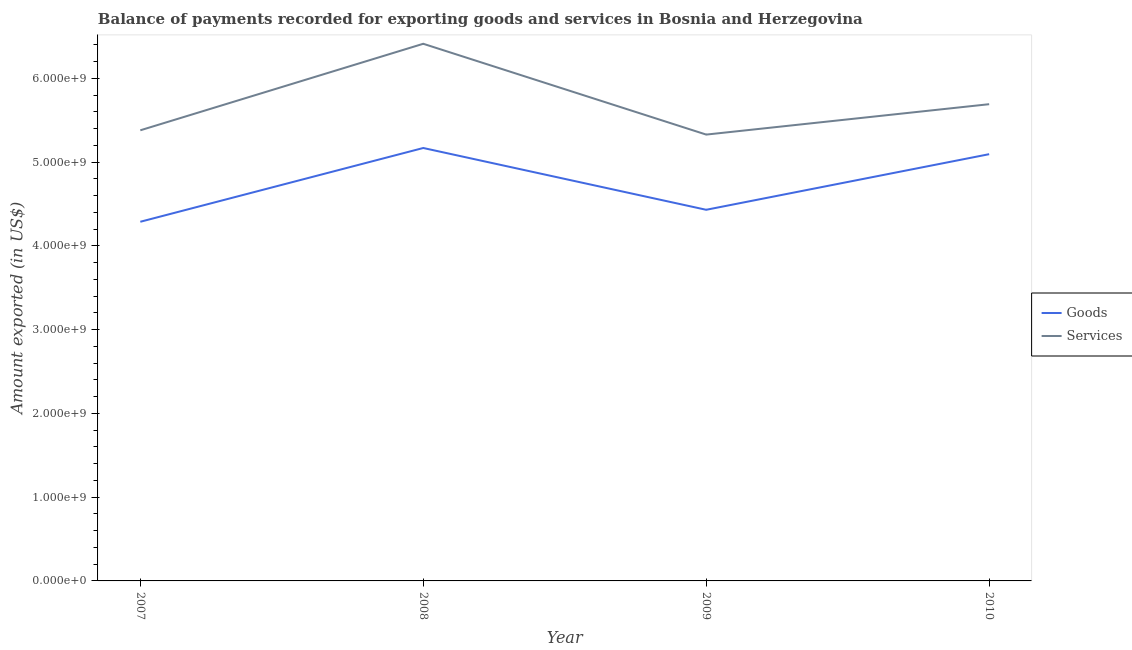Is the number of lines equal to the number of legend labels?
Give a very brief answer. Yes. What is the amount of services exported in 2007?
Keep it short and to the point. 5.38e+09. Across all years, what is the maximum amount of services exported?
Offer a terse response. 6.41e+09. Across all years, what is the minimum amount of goods exported?
Provide a succinct answer. 4.29e+09. In which year was the amount of goods exported minimum?
Make the answer very short. 2007. What is the total amount of services exported in the graph?
Offer a very short reply. 2.28e+1. What is the difference between the amount of goods exported in 2008 and that in 2009?
Offer a terse response. 7.38e+08. What is the difference between the amount of goods exported in 2010 and the amount of services exported in 2009?
Keep it short and to the point. -2.34e+08. What is the average amount of services exported per year?
Offer a very short reply. 5.70e+09. In the year 2009, what is the difference between the amount of goods exported and amount of services exported?
Your answer should be very brief. -8.98e+08. What is the ratio of the amount of services exported in 2007 to that in 2009?
Offer a very short reply. 1.01. Is the amount of services exported in 2008 less than that in 2010?
Keep it short and to the point. No. Is the difference between the amount of goods exported in 2007 and 2010 greater than the difference between the amount of services exported in 2007 and 2010?
Provide a short and direct response. No. What is the difference between the highest and the second highest amount of services exported?
Offer a very short reply. 7.21e+08. What is the difference between the highest and the lowest amount of goods exported?
Your response must be concise. 8.81e+08. Does the amount of goods exported monotonically increase over the years?
Ensure brevity in your answer.  No. How many years are there in the graph?
Give a very brief answer. 4. Does the graph contain any zero values?
Make the answer very short. No. Where does the legend appear in the graph?
Your answer should be very brief. Center right. What is the title of the graph?
Provide a succinct answer. Balance of payments recorded for exporting goods and services in Bosnia and Herzegovina. Does "Net National savings" appear as one of the legend labels in the graph?
Offer a terse response. No. What is the label or title of the X-axis?
Give a very brief answer. Year. What is the label or title of the Y-axis?
Ensure brevity in your answer.  Amount exported (in US$). What is the Amount exported (in US$) of Goods in 2007?
Offer a terse response. 4.29e+09. What is the Amount exported (in US$) in Services in 2007?
Keep it short and to the point. 5.38e+09. What is the Amount exported (in US$) in Goods in 2008?
Provide a short and direct response. 5.17e+09. What is the Amount exported (in US$) in Services in 2008?
Your answer should be compact. 6.41e+09. What is the Amount exported (in US$) of Goods in 2009?
Offer a very short reply. 4.43e+09. What is the Amount exported (in US$) in Services in 2009?
Your answer should be very brief. 5.33e+09. What is the Amount exported (in US$) in Goods in 2010?
Offer a very short reply. 5.09e+09. What is the Amount exported (in US$) of Services in 2010?
Make the answer very short. 5.69e+09. Across all years, what is the maximum Amount exported (in US$) of Goods?
Make the answer very short. 5.17e+09. Across all years, what is the maximum Amount exported (in US$) in Services?
Your answer should be very brief. 6.41e+09. Across all years, what is the minimum Amount exported (in US$) of Goods?
Make the answer very short. 4.29e+09. Across all years, what is the minimum Amount exported (in US$) in Services?
Ensure brevity in your answer.  5.33e+09. What is the total Amount exported (in US$) of Goods in the graph?
Your answer should be compact. 1.90e+1. What is the total Amount exported (in US$) in Services in the graph?
Offer a terse response. 2.28e+1. What is the difference between the Amount exported (in US$) of Goods in 2007 and that in 2008?
Provide a short and direct response. -8.81e+08. What is the difference between the Amount exported (in US$) in Services in 2007 and that in 2008?
Keep it short and to the point. -1.03e+09. What is the difference between the Amount exported (in US$) in Goods in 2007 and that in 2009?
Provide a short and direct response. -1.43e+08. What is the difference between the Amount exported (in US$) in Services in 2007 and that in 2009?
Offer a terse response. 5.11e+07. What is the difference between the Amount exported (in US$) of Goods in 2007 and that in 2010?
Offer a very short reply. -8.07e+08. What is the difference between the Amount exported (in US$) of Services in 2007 and that in 2010?
Offer a very short reply. -3.12e+08. What is the difference between the Amount exported (in US$) in Goods in 2008 and that in 2009?
Provide a succinct answer. 7.38e+08. What is the difference between the Amount exported (in US$) in Services in 2008 and that in 2009?
Make the answer very short. 1.08e+09. What is the difference between the Amount exported (in US$) in Goods in 2008 and that in 2010?
Your answer should be compact. 7.38e+07. What is the difference between the Amount exported (in US$) of Services in 2008 and that in 2010?
Offer a terse response. 7.21e+08. What is the difference between the Amount exported (in US$) of Goods in 2009 and that in 2010?
Offer a very short reply. -6.64e+08. What is the difference between the Amount exported (in US$) of Services in 2009 and that in 2010?
Keep it short and to the point. -3.63e+08. What is the difference between the Amount exported (in US$) in Goods in 2007 and the Amount exported (in US$) in Services in 2008?
Provide a succinct answer. -2.12e+09. What is the difference between the Amount exported (in US$) in Goods in 2007 and the Amount exported (in US$) in Services in 2009?
Keep it short and to the point. -1.04e+09. What is the difference between the Amount exported (in US$) in Goods in 2007 and the Amount exported (in US$) in Services in 2010?
Provide a short and direct response. -1.40e+09. What is the difference between the Amount exported (in US$) in Goods in 2008 and the Amount exported (in US$) in Services in 2009?
Your answer should be compact. -1.60e+08. What is the difference between the Amount exported (in US$) of Goods in 2008 and the Amount exported (in US$) of Services in 2010?
Provide a short and direct response. -5.23e+08. What is the difference between the Amount exported (in US$) in Goods in 2009 and the Amount exported (in US$) in Services in 2010?
Offer a terse response. -1.26e+09. What is the average Amount exported (in US$) in Goods per year?
Your response must be concise. 4.75e+09. What is the average Amount exported (in US$) in Services per year?
Your answer should be compact. 5.70e+09. In the year 2007, what is the difference between the Amount exported (in US$) in Goods and Amount exported (in US$) in Services?
Your answer should be compact. -1.09e+09. In the year 2008, what is the difference between the Amount exported (in US$) of Goods and Amount exported (in US$) of Services?
Offer a terse response. -1.24e+09. In the year 2009, what is the difference between the Amount exported (in US$) in Goods and Amount exported (in US$) in Services?
Your response must be concise. -8.98e+08. In the year 2010, what is the difference between the Amount exported (in US$) of Goods and Amount exported (in US$) of Services?
Your answer should be very brief. -5.97e+08. What is the ratio of the Amount exported (in US$) in Goods in 2007 to that in 2008?
Your answer should be very brief. 0.83. What is the ratio of the Amount exported (in US$) of Services in 2007 to that in 2008?
Offer a very short reply. 0.84. What is the ratio of the Amount exported (in US$) of Goods in 2007 to that in 2009?
Your answer should be compact. 0.97. What is the ratio of the Amount exported (in US$) in Services in 2007 to that in 2009?
Your answer should be compact. 1.01. What is the ratio of the Amount exported (in US$) of Goods in 2007 to that in 2010?
Provide a succinct answer. 0.84. What is the ratio of the Amount exported (in US$) of Services in 2007 to that in 2010?
Provide a succinct answer. 0.95. What is the ratio of the Amount exported (in US$) of Goods in 2008 to that in 2009?
Give a very brief answer. 1.17. What is the ratio of the Amount exported (in US$) of Services in 2008 to that in 2009?
Offer a very short reply. 1.2. What is the ratio of the Amount exported (in US$) of Goods in 2008 to that in 2010?
Provide a short and direct response. 1.01. What is the ratio of the Amount exported (in US$) of Services in 2008 to that in 2010?
Your answer should be very brief. 1.13. What is the ratio of the Amount exported (in US$) of Goods in 2009 to that in 2010?
Provide a short and direct response. 0.87. What is the ratio of the Amount exported (in US$) of Services in 2009 to that in 2010?
Keep it short and to the point. 0.94. What is the difference between the highest and the second highest Amount exported (in US$) of Goods?
Provide a succinct answer. 7.38e+07. What is the difference between the highest and the second highest Amount exported (in US$) of Services?
Give a very brief answer. 7.21e+08. What is the difference between the highest and the lowest Amount exported (in US$) of Goods?
Your answer should be compact. 8.81e+08. What is the difference between the highest and the lowest Amount exported (in US$) of Services?
Keep it short and to the point. 1.08e+09. 